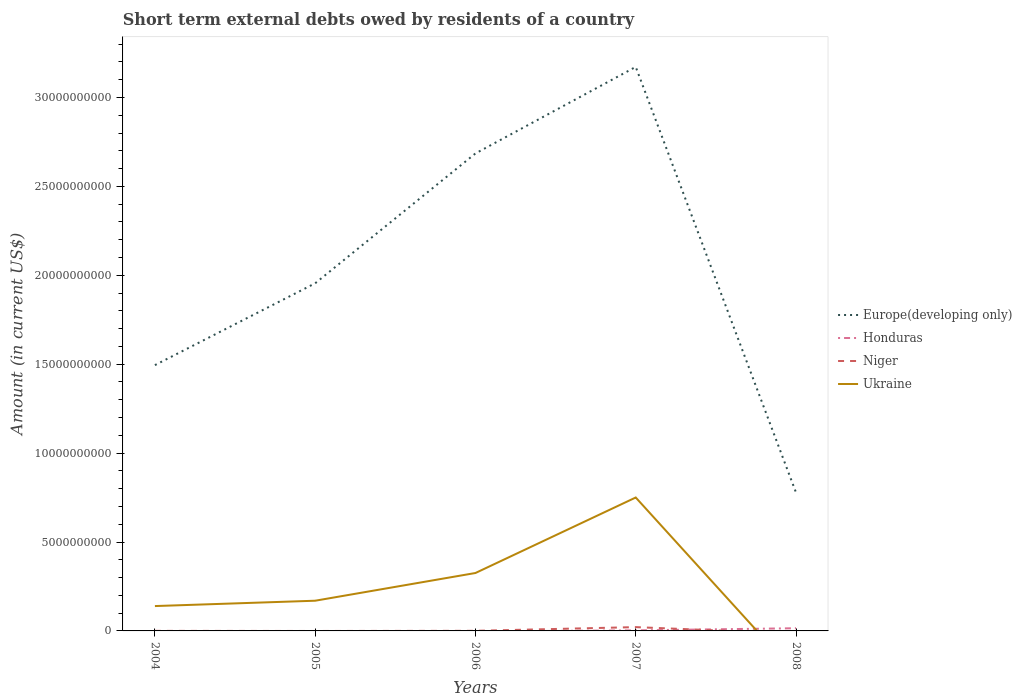How many different coloured lines are there?
Provide a short and direct response. 4. Across all years, what is the maximum amount of short-term external debts owed by residents in Niger?
Make the answer very short. 0. What is the total amount of short-term external debts owed by residents in Ukraine in the graph?
Ensure brevity in your answer.  -4.25e+09. What is the difference between the highest and the second highest amount of short-term external debts owed by residents in Niger?
Offer a terse response. 2.14e+08. What is the difference between the highest and the lowest amount of short-term external debts owed by residents in Honduras?
Your answer should be very brief. 1. Is the amount of short-term external debts owed by residents in Ukraine strictly greater than the amount of short-term external debts owed by residents in Europe(developing only) over the years?
Offer a terse response. Yes. How many lines are there?
Provide a short and direct response. 4. How many years are there in the graph?
Ensure brevity in your answer.  5. What is the difference between two consecutive major ticks on the Y-axis?
Offer a very short reply. 5.00e+09. Are the values on the major ticks of Y-axis written in scientific E-notation?
Offer a terse response. No. Does the graph contain any zero values?
Your answer should be compact. Yes. Does the graph contain grids?
Provide a short and direct response. No. How many legend labels are there?
Provide a short and direct response. 4. How are the legend labels stacked?
Your answer should be very brief. Vertical. What is the title of the graph?
Keep it short and to the point. Short term external debts owed by residents of a country. What is the label or title of the X-axis?
Your response must be concise. Years. What is the Amount (in current US$) in Europe(developing only) in 2004?
Your response must be concise. 1.49e+1. What is the Amount (in current US$) of Niger in 2004?
Offer a very short reply. 3.30e+06. What is the Amount (in current US$) in Ukraine in 2004?
Keep it short and to the point. 1.40e+09. What is the Amount (in current US$) of Europe(developing only) in 2005?
Ensure brevity in your answer.  1.96e+1. What is the Amount (in current US$) of Honduras in 2005?
Make the answer very short. 0. What is the Amount (in current US$) in Ukraine in 2005?
Provide a short and direct response. 1.70e+09. What is the Amount (in current US$) in Europe(developing only) in 2006?
Keep it short and to the point. 2.69e+1. What is the Amount (in current US$) of Honduras in 2006?
Your answer should be very brief. 0. What is the Amount (in current US$) of Ukraine in 2006?
Provide a short and direct response. 3.26e+09. What is the Amount (in current US$) in Europe(developing only) in 2007?
Your answer should be compact. 3.17e+1. What is the Amount (in current US$) of Honduras in 2007?
Give a very brief answer. 3.09e+07. What is the Amount (in current US$) in Niger in 2007?
Give a very brief answer. 2.14e+08. What is the Amount (in current US$) of Ukraine in 2007?
Offer a very short reply. 7.50e+09. What is the Amount (in current US$) of Europe(developing only) in 2008?
Ensure brevity in your answer.  7.78e+09. What is the Amount (in current US$) in Honduras in 2008?
Give a very brief answer. 1.51e+08. What is the Amount (in current US$) in Niger in 2008?
Your answer should be compact. 0. Across all years, what is the maximum Amount (in current US$) in Europe(developing only)?
Keep it short and to the point. 3.17e+1. Across all years, what is the maximum Amount (in current US$) in Honduras?
Offer a terse response. 1.51e+08. Across all years, what is the maximum Amount (in current US$) in Niger?
Your response must be concise. 2.14e+08. Across all years, what is the maximum Amount (in current US$) in Ukraine?
Offer a terse response. 7.50e+09. Across all years, what is the minimum Amount (in current US$) in Europe(developing only)?
Keep it short and to the point. 7.78e+09. Across all years, what is the minimum Amount (in current US$) in Honduras?
Give a very brief answer. 0. Across all years, what is the minimum Amount (in current US$) of Niger?
Your answer should be very brief. 0. Across all years, what is the minimum Amount (in current US$) of Ukraine?
Make the answer very short. 0. What is the total Amount (in current US$) of Europe(developing only) in the graph?
Your response must be concise. 1.01e+11. What is the total Amount (in current US$) of Honduras in the graph?
Your answer should be compact. 1.82e+08. What is the total Amount (in current US$) in Niger in the graph?
Your response must be concise. 2.23e+08. What is the total Amount (in current US$) of Ukraine in the graph?
Offer a very short reply. 1.39e+1. What is the difference between the Amount (in current US$) in Europe(developing only) in 2004 and that in 2005?
Give a very brief answer. -4.60e+09. What is the difference between the Amount (in current US$) in Ukraine in 2004 and that in 2005?
Your answer should be compact. -3.00e+08. What is the difference between the Amount (in current US$) in Europe(developing only) in 2004 and that in 2006?
Offer a very short reply. -1.19e+1. What is the difference between the Amount (in current US$) in Niger in 2004 and that in 2006?
Ensure brevity in your answer.  -2.70e+06. What is the difference between the Amount (in current US$) in Ukraine in 2004 and that in 2006?
Make the answer very short. -1.86e+09. What is the difference between the Amount (in current US$) of Europe(developing only) in 2004 and that in 2007?
Offer a terse response. -1.68e+1. What is the difference between the Amount (in current US$) in Niger in 2004 and that in 2007?
Ensure brevity in your answer.  -2.11e+08. What is the difference between the Amount (in current US$) in Ukraine in 2004 and that in 2007?
Your answer should be very brief. -6.11e+09. What is the difference between the Amount (in current US$) in Europe(developing only) in 2004 and that in 2008?
Offer a very short reply. 7.17e+09. What is the difference between the Amount (in current US$) of Europe(developing only) in 2005 and that in 2006?
Your answer should be very brief. -7.30e+09. What is the difference between the Amount (in current US$) in Ukraine in 2005 and that in 2006?
Ensure brevity in your answer.  -1.56e+09. What is the difference between the Amount (in current US$) of Europe(developing only) in 2005 and that in 2007?
Your answer should be compact. -1.22e+1. What is the difference between the Amount (in current US$) in Ukraine in 2005 and that in 2007?
Your answer should be compact. -5.81e+09. What is the difference between the Amount (in current US$) of Europe(developing only) in 2005 and that in 2008?
Provide a succinct answer. 1.18e+1. What is the difference between the Amount (in current US$) in Europe(developing only) in 2006 and that in 2007?
Ensure brevity in your answer.  -4.87e+09. What is the difference between the Amount (in current US$) in Niger in 2006 and that in 2007?
Keep it short and to the point. -2.08e+08. What is the difference between the Amount (in current US$) in Ukraine in 2006 and that in 2007?
Offer a terse response. -4.25e+09. What is the difference between the Amount (in current US$) in Europe(developing only) in 2006 and that in 2008?
Provide a short and direct response. 1.91e+1. What is the difference between the Amount (in current US$) in Europe(developing only) in 2007 and that in 2008?
Offer a terse response. 2.39e+1. What is the difference between the Amount (in current US$) of Honduras in 2007 and that in 2008?
Offer a very short reply. -1.20e+08. What is the difference between the Amount (in current US$) in Europe(developing only) in 2004 and the Amount (in current US$) in Ukraine in 2005?
Give a very brief answer. 1.33e+1. What is the difference between the Amount (in current US$) of Niger in 2004 and the Amount (in current US$) of Ukraine in 2005?
Offer a terse response. -1.70e+09. What is the difference between the Amount (in current US$) in Europe(developing only) in 2004 and the Amount (in current US$) in Niger in 2006?
Give a very brief answer. 1.49e+1. What is the difference between the Amount (in current US$) in Europe(developing only) in 2004 and the Amount (in current US$) in Ukraine in 2006?
Give a very brief answer. 1.17e+1. What is the difference between the Amount (in current US$) in Niger in 2004 and the Amount (in current US$) in Ukraine in 2006?
Your answer should be compact. -3.25e+09. What is the difference between the Amount (in current US$) of Europe(developing only) in 2004 and the Amount (in current US$) of Honduras in 2007?
Your response must be concise. 1.49e+1. What is the difference between the Amount (in current US$) in Europe(developing only) in 2004 and the Amount (in current US$) in Niger in 2007?
Provide a short and direct response. 1.47e+1. What is the difference between the Amount (in current US$) of Europe(developing only) in 2004 and the Amount (in current US$) of Ukraine in 2007?
Keep it short and to the point. 7.44e+09. What is the difference between the Amount (in current US$) of Niger in 2004 and the Amount (in current US$) of Ukraine in 2007?
Ensure brevity in your answer.  -7.50e+09. What is the difference between the Amount (in current US$) of Europe(developing only) in 2004 and the Amount (in current US$) of Honduras in 2008?
Give a very brief answer. 1.48e+1. What is the difference between the Amount (in current US$) of Europe(developing only) in 2005 and the Amount (in current US$) of Niger in 2006?
Make the answer very short. 1.95e+1. What is the difference between the Amount (in current US$) in Europe(developing only) in 2005 and the Amount (in current US$) in Ukraine in 2006?
Provide a succinct answer. 1.63e+1. What is the difference between the Amount (in current US$) in Europe(developing only) in 2005 and the Amount (in current US$) in Honduras in 2007?
Your answer should be compact. 1.95e+1. What is the difference between the Amount (in current US$) of Europe(developing only) in 2005 and the Amount (in current US$) of Niger in 2007?
Provide a short and direct response. 1.93e+1. What is the difference between the Amount (in current US$) in Europe(developing only) in 2005 and the Amount (in current US$) in Ukraine in 2007?
Keep it short and to the point. 1.20e+1. What is the difference between the Amount (in current US$) in Europe(developing only) in 2005 and the Amount (in current US$) in Honduras in 2008?
Make the answer very short. 1.94e+1. What is the difference between the Amount (in current US$) in Europe(developing only) in 2006 and the Amount (in current US$) in Honduras in 2007?
Your response must be concise. 2.68e+1. What is the difference between the Amount (in current US$) of Europe(developing only) in 2006 and the Amount (in current US$) of Niger in 2007?
Provide a short and direct response. 2.66e+1. What is the difference between the Amount (in current US$) in Europe(developing only) in 2006 and the Amount (in current US$) in Ukraine in 2007?
Ensure brevity in your answer.  1.94e+1. What is the difference between the Amount (in current US$) of Niger in 2006 and the Amount (in current US$) of Ukraine in 2007?
Provide a succinct answer. -7.50e+09. What is the difference between the Amount (in current US$) of Europe(developing only) in 2006 and the Amount (in current US$) of Honduras in 2008?
Provide a short and direct response. 2.67e+1. What is the difference between the Amount (in current US$) of Europe(developing only) in 2007 and the Amount (in current US$) of Honduras in 2008?
Ensure brevity in your answer.  3.16e+1. What is the average Amount (in current US$) in Europe(developing only) per year?
Make the answer very short. 2.02e+1. What is the average Amount (in current US$) in Honduras per year?
Make the answer very short. 3.64e+07. What is the average Amount (in current US$) of Niger per year?
Make the answer very short. 4.47e+07. What is the average Amount (in current US$) of Ukraine per year?
Provide a short and direct response. 2.77e+09. In the year 2004, what is the difference between the Amount (in current US$) of Europe(developing only) and Amount (in current US$) of Niger?
Your answer should be compact. 1.49e+1. In the year 2004, what is the difference between the Amount (in current US$) in Europe(developing only) and Amount (in current US$) in Ukraine?
Provide a succinct answer. 1.36e+1. In the year 2004, what is the difference between the Amount (in current US$) of Niger and Amount (in current US$) of Ukraine?
Offer a terse response. -1.39e+09. In the year 2005, what is the difference between the Amount (in current US$) of Europe(developing only) and Amount (in current US$) of Ukraine?
Make the answer very short. 1.79e+1. In the year 2006, what is the difference between the Amount (in current US$) in Europe(developing only) and Amount (in current US$) in Niger?
Your answer should be very brief. 2.68e+1. In the year 2006, what is the difference between the Amount (in current US$) in Europe(developing only) and Amount (in current US$) in Ukraine?
Make the answer very short. 2.36e+1. In the year 2006, what is the difference between the Amount (in current US$) of Niger and Amount (in current US$) of Ukraine?
Your answer should be very brief. -3.25e+09. In the year 2007, what is the difference between the Amount (in current US$) of Europe(developing only) and Amount (in current US$) of Honduras?
Provide a short and direct response. 3.17e+1. In the year 2007, what is the difference between the Amount (in current US$) of Europe(developing only) and Amount (in current US$) of Niger?
Your response must be concise. 3.15e+1. In the year 2007, what is the difference between the Amount (in current US$) of Europe(developing only) and Amount (in current US$) of Ukraine?
Your response must be concise. 2.42e+1. In the year 2007, what is the difference between the Amount (in current US$) in Honduras and Amount (in current US$) in Niger?
Provide a short and direct response. -1.83e+08. In the year 2007, what is the difference between the Amount (in current US$) of Honduras and Amount (in current US$) of Ukraine?
Provide a succinct answer. -7.47e+09. In the year 2007, what is the difference between the Amount (in current US$) of Niger and Amount (in current US$) of Ukraine?
Your response must be concise. -7.29e+09. In the year 2008, what is the difference between the Amount (in current US$) of Europe(developing only) and Amount (in current US$) of Honduras?
Provide a succinct answer. 7.63e+09. What is the ratio of the Amount (in current US$) in Europe(developing only) in 2004 to that in 2005?
Provide a succinct answer. 0.76. What is the ratio of the Amount (in current US$) of Ukraine in 2004 to that in 2005?
Your answer should be compact. 0.82. What is the ratio of the Amount (in current US$) in Europe(developing only) in 2004 to that in 2006?
Provide a succinct answer. 0.56. What is the ratio of the Amount (in current US$) in Niger in 2004 to that in 2006?
Offer a terse response. 0.55. What is the ratio of the Amount (in current US$) in Ukraine in 2004 to that in 2006?
Provide a short and direct response. 0.43. What is the ratio of the Amount (in current US$) in Europe(developing only) in 2004 to that in 2007?
Make the answer very short. 0.47. What is the ratio of the Amount (in current US$) in Niger in 2004 to that in 2007?
Provide a succinct answer. 0.02. What is the ratio of the Amount (in current US$) in Ukraine in 2004 to that in 2007?
Keep it short and to the point. 0.19. What is the ratio of the Amount (in current US$) in Europe(developing only) in 2004 to that in 2008?
Offer a terse response. 1.92. What is the ratio of the Amount (in current US$) of Europe(developing only) in 2005 to that in 2006?
Your answer should be compact. 0.73. What is the ratio of the Amount (in current US$) in Ukraine in 2005 to that in 2006?
Your answer should be compact. 0.52. What is the ratio of the Amount (in current US$) of Europe(developing only) in 2005 to that in 2007?
Make the answer very short. 0.62. What is the ratio of the Amount (in current US$) in Ukraine in 2005 to that in 2007?
Offer a very short reply. 0.23. What is the ratio of the Amount (in current US$) of Europe(developing only) in 2005 to that in 2008?
Provide a short and direct response. 2.51. What is the ratio of the Amount (in current US$) in Europe(developing only) in 2006 to that in 2007?
Make the answer very short. 0.85. What is the ratio of the Amount (in current US$) of Niger in 2006 to that in 2007?
Provide a succinct answer. 0.03. What is the ratio of the Amount (in current US$) in Ukraine in 2006 to that in 2007?
Your answer should be compact. 0.43. What is the ratio of the Amount (in current US$) of Europe(developing only) in 2006 to that in 2008?
Give a very brief answer. 3.45. What is the ratio of the Amount (in current US$) of Europe(developing only) in 2007 to that in 2008?
Provide a succinct answer. 4.08. What is the ratio of the Amount (in current US$) of Honduras in 2007 to that in 2008?
Your response must be concise. 0.2. What is the difference between the highest and the second highest Amount (in current US$) in Europe(developing only)?
Provide a short and direct response. 4.87e+09. What is the difference between the highest and the second highest Amount (in current US$) of Niger?
Offer a very short reply. 2.08e+08. What is the difference between the highest and the second highest Amount (in current US$) of Ukraine?
Offer a terse response. 4.25e+09. What is the difference between the highest and the lowest Amount (in current US$) in Europe(developing only)?
Your response must be concise. 2.39e+1. What is the difference between the highest and the lowest Amount (in current US$) in Honduras?
Keep it short and to the point. 1.51e+08. What is the difference between the highest and the lowest Amount (in current US$) of Niger?
Provide a succinct answer. 2.14e+08. What is the difference between the highest and the lowest Amount (in current US$) of Ukraine?
Ensure brevity in your answer.  7.50e+09. 